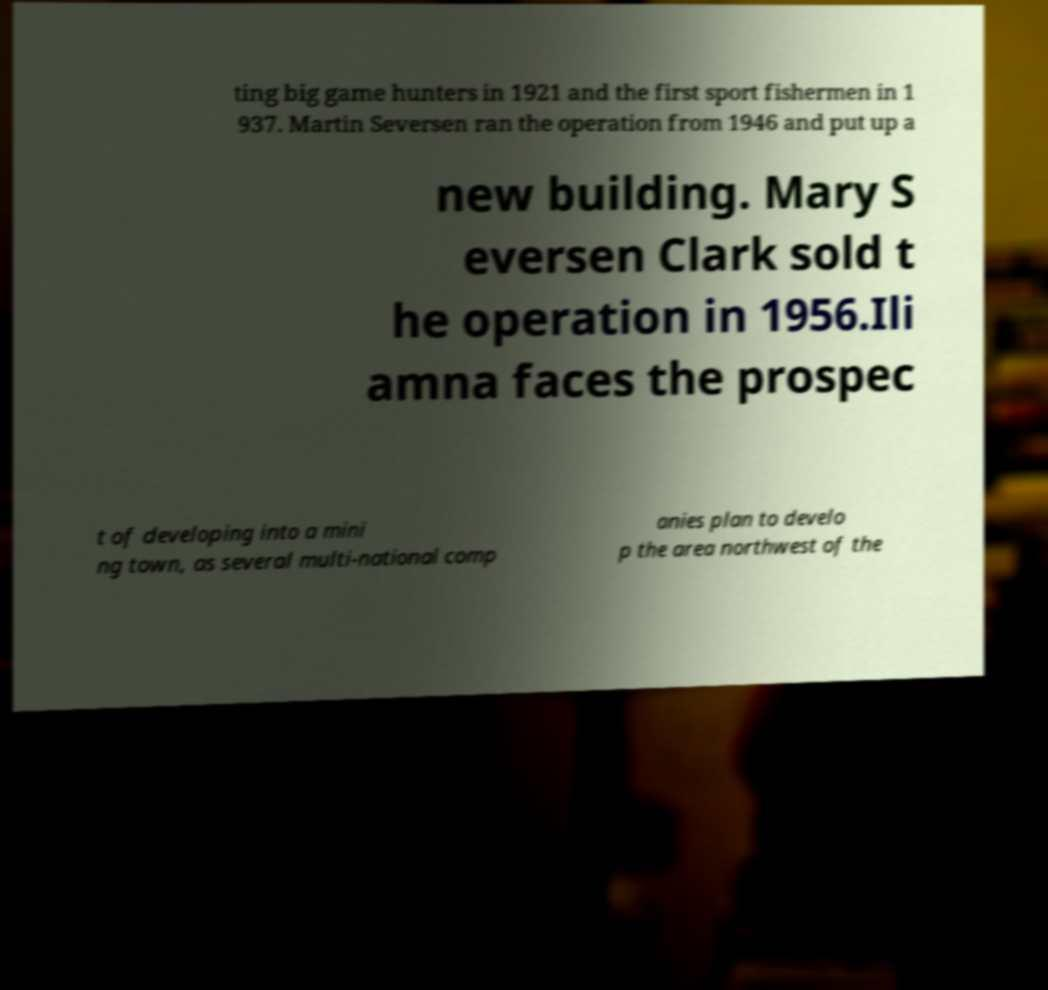I need the written content from this picture converted into text. Can you do that? ting big game hunters in 1921 and the first sport fishermen in 1 937. Martin Seversen ran the operation from 1946 and put up a new building. Mary S eversen Clark sold t he operation in 1956.Ili amna faces the prospec t of developing into a mini ng town, as several multi-national comp anies plan to develo p the area northwest of the 